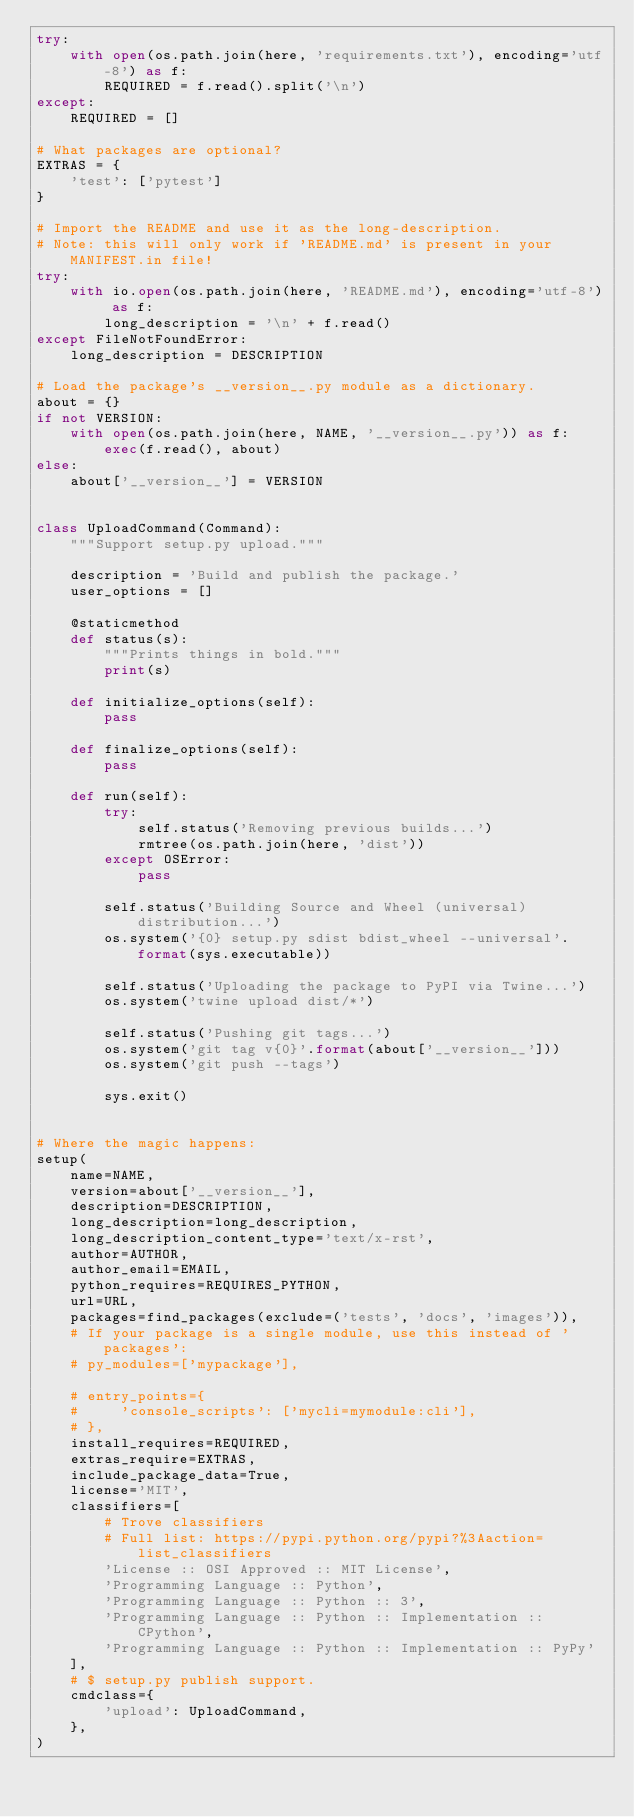<code> <loc_0><loc_0><loc_500><loc_500><_Python_>try:
    with open(os.path.join(here, 'requirements.txt'), encoding='utf-8') as f:
        REQUIRED = f.read().split('\n')
except:
    REQUIRED = []

# What packages are optional?
EXTRAS = {
    'test': ['pytest']
}

# Import the README and use it as the long-description.
# Note: this will only work if 'README.md' is present in your MANIFEST.in file!
try:
    with io.open(os.path.join(here, 'README.md'), encoding='utf-8') as f:
        long_description = '\n' + f.read()
except FileNotFoundError:
    long_description = DESCRIPTION

# Load the package's __version__.py module as a dictionary.
about = {}
if not VERSION:
    with open(os.path.join(here, NAME, '__version__.py')) as f:
        exec(f.read(), about)
else:
    about['__version__'] = VERSION


class UploadCommand(Command):
    """Support setup.py upload."""

    description = 'Build and publish the package.'
    user_options = []

    @staticmethod
    def status(s):
        """Prints things in bold."""
        print(s)

    def initialize_options(self):
        pass

    def finalize_options(self):
        pass

    def run(self):
        try:
            self.status('Removing previous builds...')
            rmtree(os.path.join(here, 'dist'))
        except OSError:
            pass

        self.status('Building Source and Wheel (universal) distribution...')
        os.system('{0} setup.py sdist bdist_wheel --universal'.format(sys.executable))

        self.status('Uploading the package to PyPI via Twine...')
        os.system('twine upload dist/*')

        self.status('Pushing git tags...')
        os.system('git tag v{0}'.format(about['__version__']))
        os.system('git push --tags')

        sys.exit()


# Where the magic happens:
setup(
    name=NAME,
    version=about['__version__'],
    description=DESCRIPTION,
    long_description=long_description,
    long_description_content_type='text/x-rst',
    author=AUTHOR,
    author_email=EMAIL,
    python_requires=REQUIRES_PYTHON,
    url=URL,
    packages=find_packages(exclude=('tests', 'docs', 'images')),
    # If your package is a single module, use this instead of 'packages':
    # py_modules=['mypackage'],

    # entry_points={
    #     'console_scripts': ['mycli=mymodule:cli'],
    # },
    install_requires=REQUIRED,
    extras_require=EXTRAS,
    include_package_data=True,
    license='MIT',
    classifiers=[
        # Trove classifiers
        # Full list: https://pypi.python.org/pypi?%3Aaction=list_classifiers
        'License :: OSI Approved :: MIT License',
        'Programming Language :: Python',
        'Programming Language :: Python :: 3',
        'Programming Language :: Python :: Implementation :: CPython',
        'Programming Language :: Python :: Implementation :: PyPy'
    ],
    # $ setup.py publish support.
    cmdclass={
        'upload': UploadCommand,
    },
)</code> 